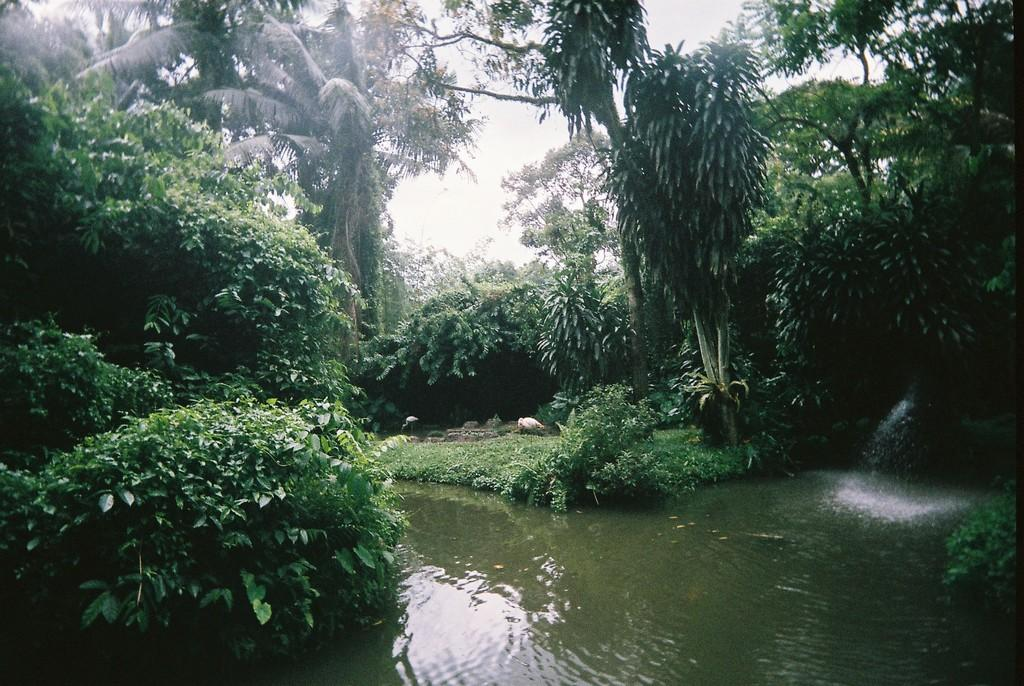What type of vegetation can be seen in the image? There are trees with branches and leaves in the image. What other types of plants are present in the image? There are bushes in the image. What body of water is visible in the image? There is a pond with water flowing in the image. What animals can be seen in the image? There are birds visible in the image. What part of the natural environment is visible in the image? The sky is visible in the image. What type of paste is being used to hold the pin in the image? There is no paste or pin present in the image; it features trees, bushes, a pond, birds, and the sky. 